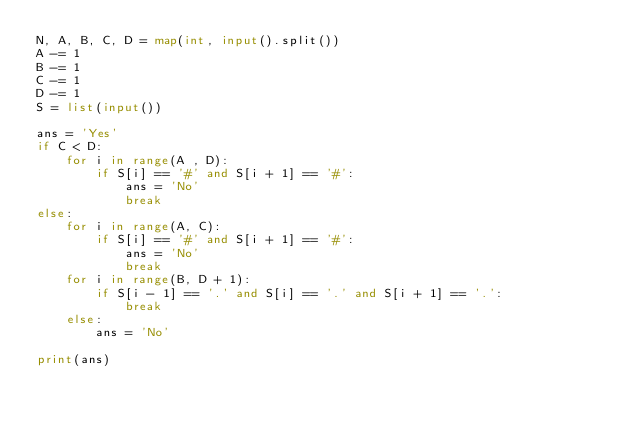Convert code to text. <code><loc_0><loc_0><loc_500><loc_500><_Python_>N, A, B, C, D = map(int, input().split())
A -= 1
B -= 1
C -= 1
D -= 1
S = list(input())
 
ans = 'Yes'
if C < D:
    for i in range(A , D):
        if S[i] == '#' and S[i + 1] == '#':
            ans = 'No'
            break
else:
    for i in range(A, C):
        if S[i] == '#' and S[i + 1] == '#':
            ans = 'No'
            break
    for i in range(B, D + 1):
        if S[i - 1] == '.' and S[i] == '.' and S[i + 1] == '.':
            break
    else:
        ans = 'No'
            
print(ans)</code> 